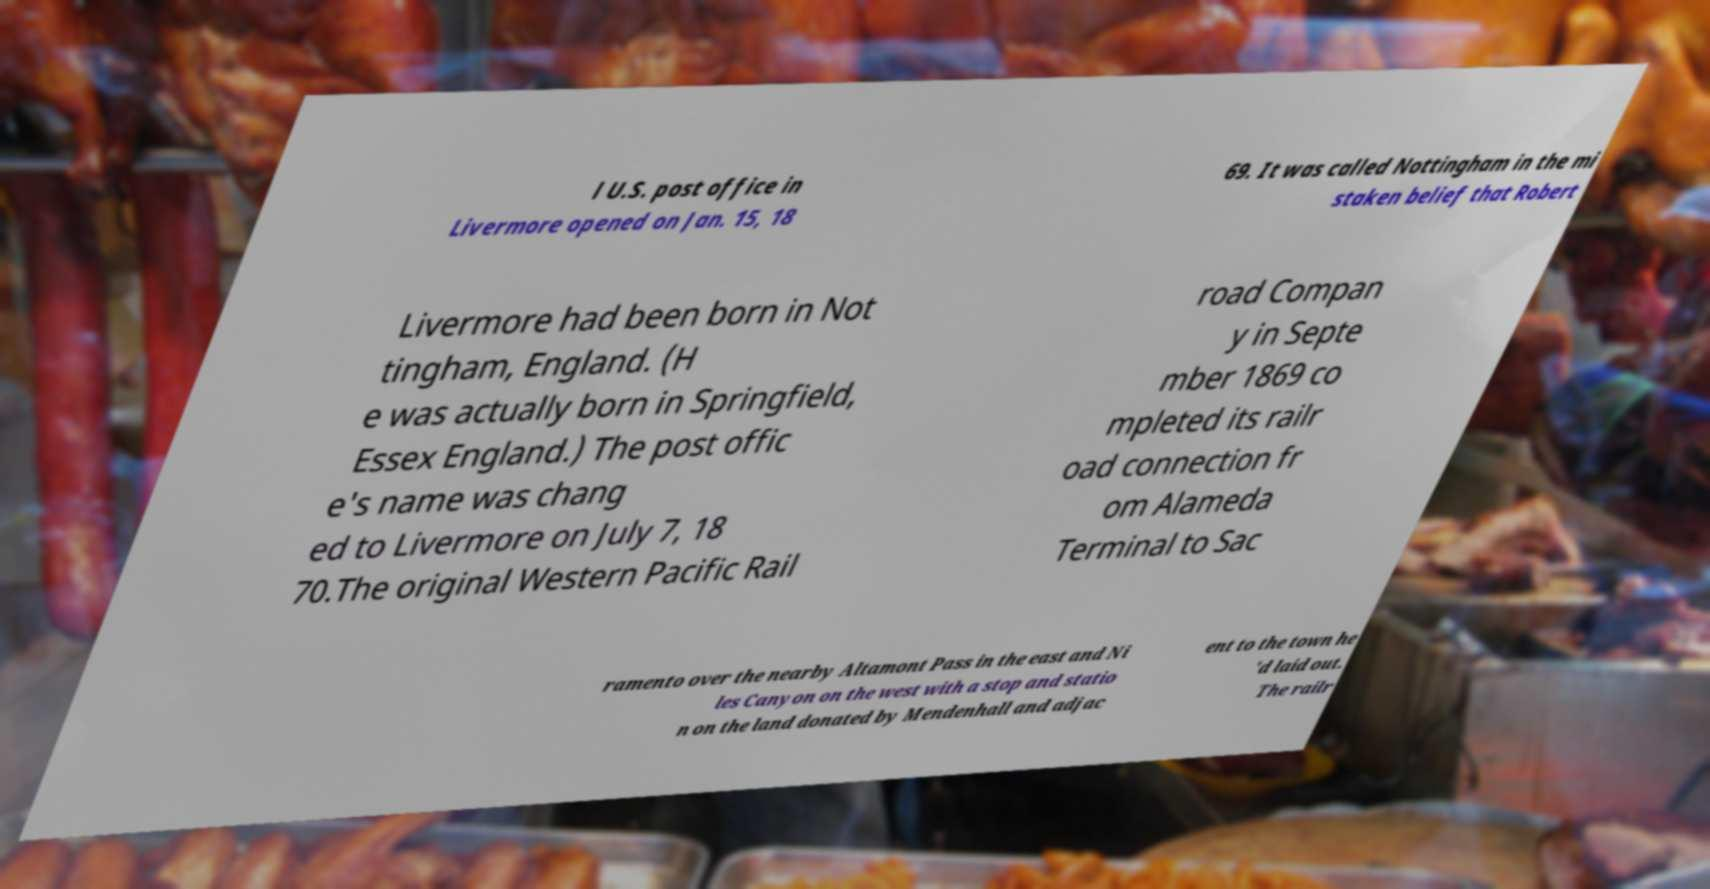Please read and relay the text visible in this image. What does it say? l U.S. post office in Livermore opened on Jan. 15, 18 69. It was called Nottingham in the mi staken belief that Robert Livermore had been born in Not tingham, England. (H e was actually born in Springfield, Essex England.) The post offic e's name was chang ed to Livermore on July 7, 18 70.The original Western Pacific Rail road Compan y in Septe mber 1869 co mpleted its railr oad connection fr om Alameda Terminal to Sac ramento over the nearby Altamont Pass in the east and Ni les Canyon on the west with a stop and statio n on the land donated by Mendenhall and adjac ent to the town he 'd laid out. The railr 